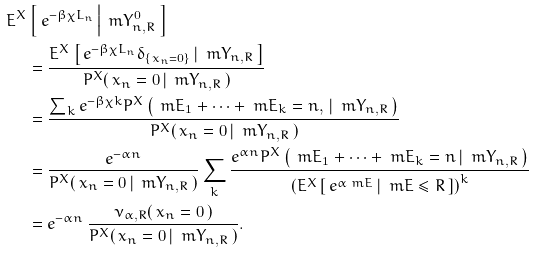<formula> <loc_0><loc_0><loc_500><loc_500>E ^ { X } & \left [ \, e ^ { - \beta \chi L _ { n } } \, \Big | \, \ m Y _ { n , R } ^ { 0 } \, \right ] \\ & = \frac { E ^ { X } \left [ \, e ^ { - \beta \chi L _ { n } } \delta _ { \{ x _ { n } = 0 \} } \, | \, \ m Y _ { n , R } \, \right ] } { P ^ { X } ( \, x _ { n } = 0 \, | \, \ m Y _ { n , R } \, ) } \\ & = \frac { \sum _ { k } e ^ { - \beta \chi k } P ^ { X } \left ( \, \ m E _ { 1 } + \cdots + \ m E _ { k } = n , \, | \, \ m Y _ { n , R } \, \right ) } { P ^ { X } ( \, x _ { n } = 0 \, | \, \ m Y _ { n , R } \, ) } \\ & = \frac { e ^ { - \alpha n } } { P ^ { X } ( \, x _ { n } = 0 \, | \, \ m Y _ { n , R } \, ) } \sum _ { k } \frac { e ^ { \alpha n } P ^ { X } \left ( \, \ m E _ { 1 } + \cdots + \ m E _ { k } = n \, | \, \ m Y _ { n , R } \, \right ) } { \left ( E ^ { X } \left [ \, e ^ { \alpha \ m E } \, | \, \ m E \leq R \, \right ] \right ) ^ { k } } \\ & = e ^ { - \alpha n } \, \frac { \nu _ { \alpha , R } ( \, x _ { n } = 0 \, ) } { P ^ { X } ( \, x _ { n } = 0 \, | \, \ m Y _ { n , R } \, ) } .</formula> 